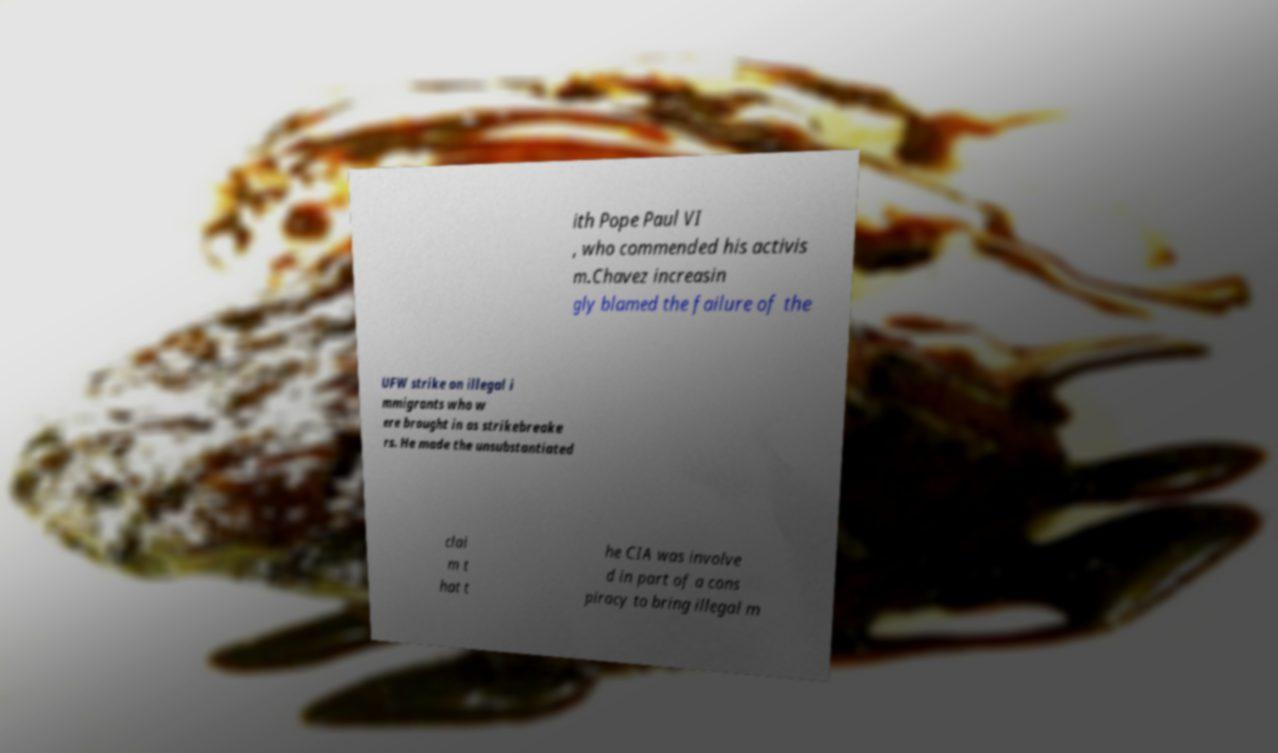For documentation purposes, I need the text within this image transcribed. Could you provide that? ith Pope Paul VI , who commended his activis m.Chavez increasin gly blamed the failure of the UFW strike on illegal i mmigrants who w ere brought in as strikebreake rs. He made the unsubstantiated clai m t hat t he CIA was involve d in part of a cons piracy to bring illegal m 